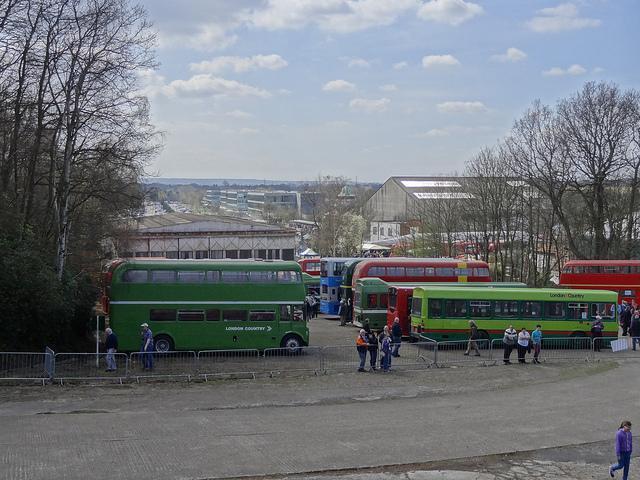How many buses are visible?
Give a very brief answer. 4. How many train cars are behind the locomotive?
Give a very brief answer. 0. 